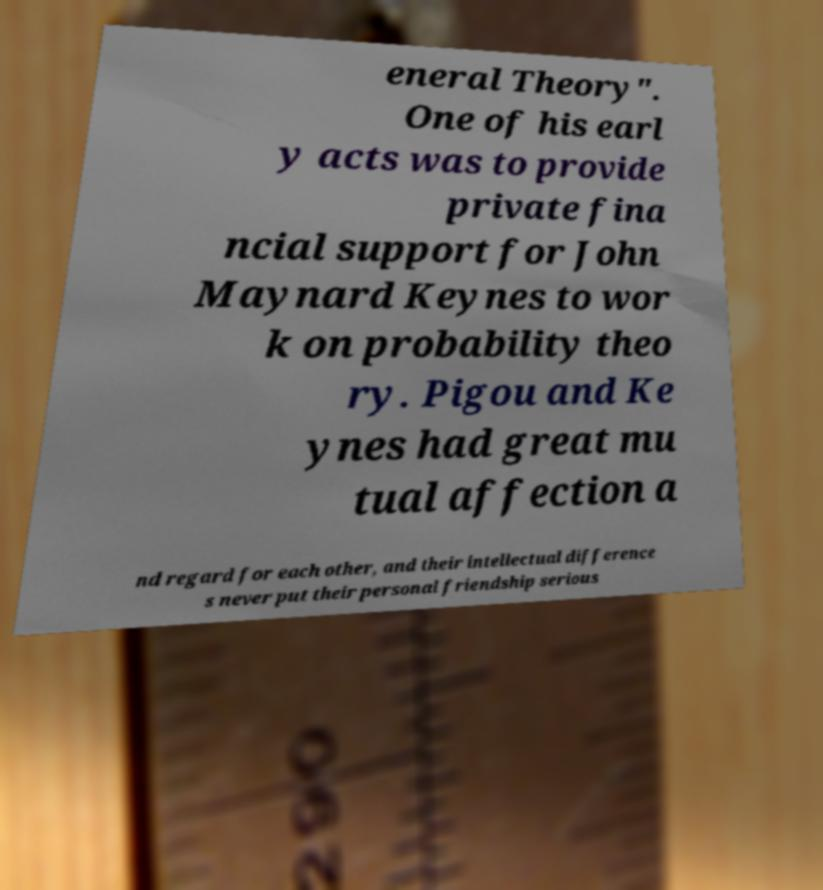Please identify and transcribe the text found in this image. eneral Theory". One of his earl y acts was to provide private fina ncial support for John Maynard Keynes to wor k on probability theo ry. Pigou and Ke ynes had great mu tual affection a nd regard for each other, and their intellectual difference s never put their personal friendship serious 